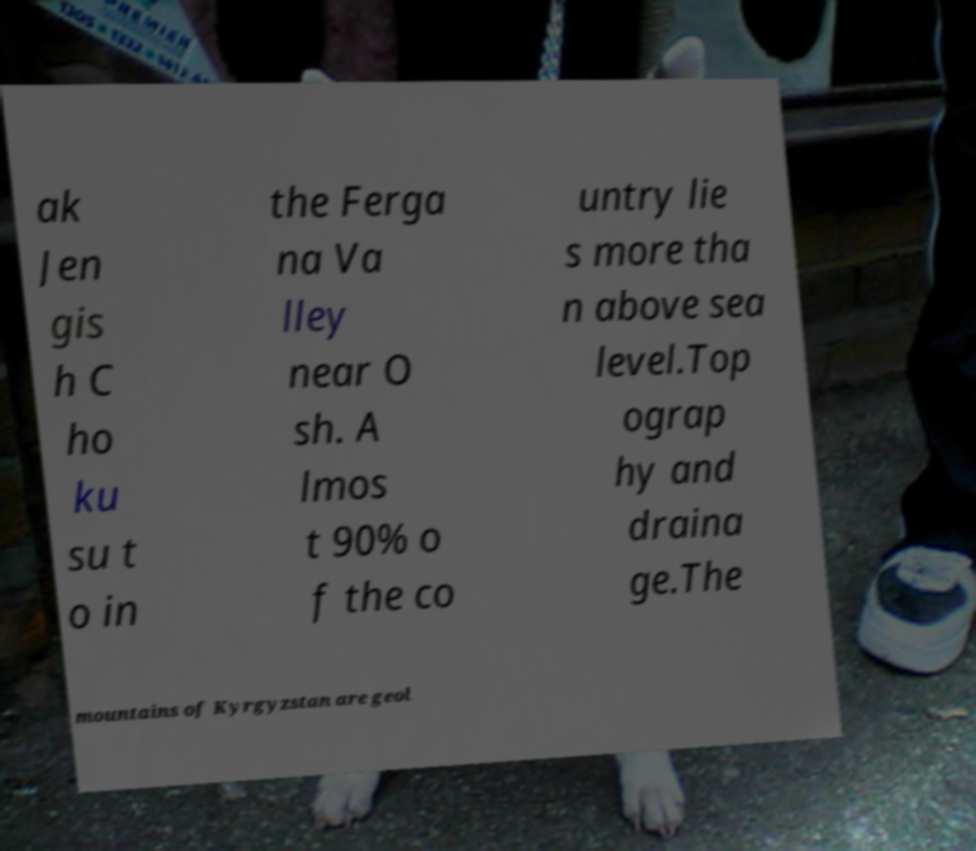There's text embedded in this image that I need extracted. Can you transcribe it verbatim? ak Jen gis h C ho ku su t o in the Ferga na Va lley near O sh. A lmos t 90% o f the co untry lie s more tha n above sea level.Top ograp hy and draina ge.The mountains of Kyrgyzstan are geol 